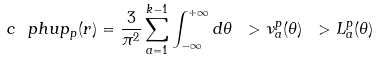Convert formula to latex. <formula><loc_0><loc_0><loc_500><loc_500>c \ p h u p _ { p } ( r ) = \frac { 3 } { \pi ^ { 2 } } \sum _ { a = 1 } ^ { k - 1 } \int _ { - \infty } ^ { + \infty } d \theta \ > \nu _ { a } ^ { p } ( \theta ) \ > L _ { a } ^ { p } ( \theta )</formula> 